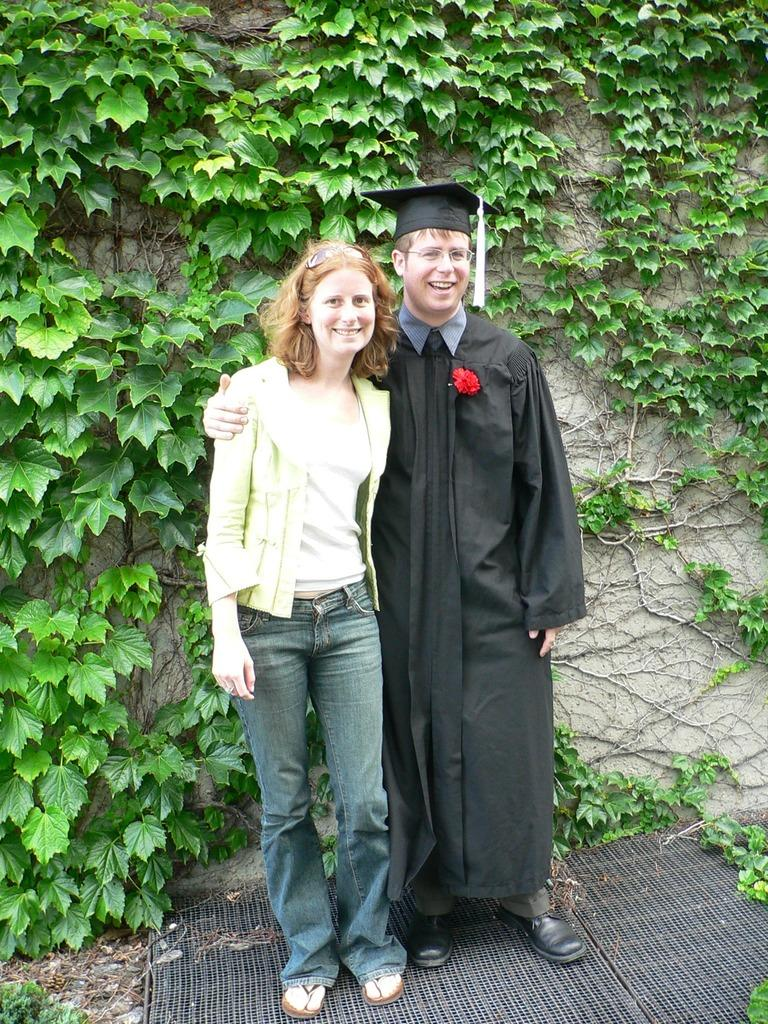How many people are in the image? There are two people in the image, a woman and a man. What are the people in the image doing? The woman and the man are standing and giving a pose for the picture. What is the emotional expression of the people in the image? The woman and the man are smiling in the image. What can be seen in the background of the image? There is a wall in the background of the image, and a creeper plant is attached to the wall. What type of skirt is the woman wearing in the image? There is no information about the woman's skirt in the image, as the focus is on her standing and smiling pose with the man. How many things can be seen on the ground in the image? The image does not provide information about any objects on the ground, so it is impossible to determine the number of things present. 